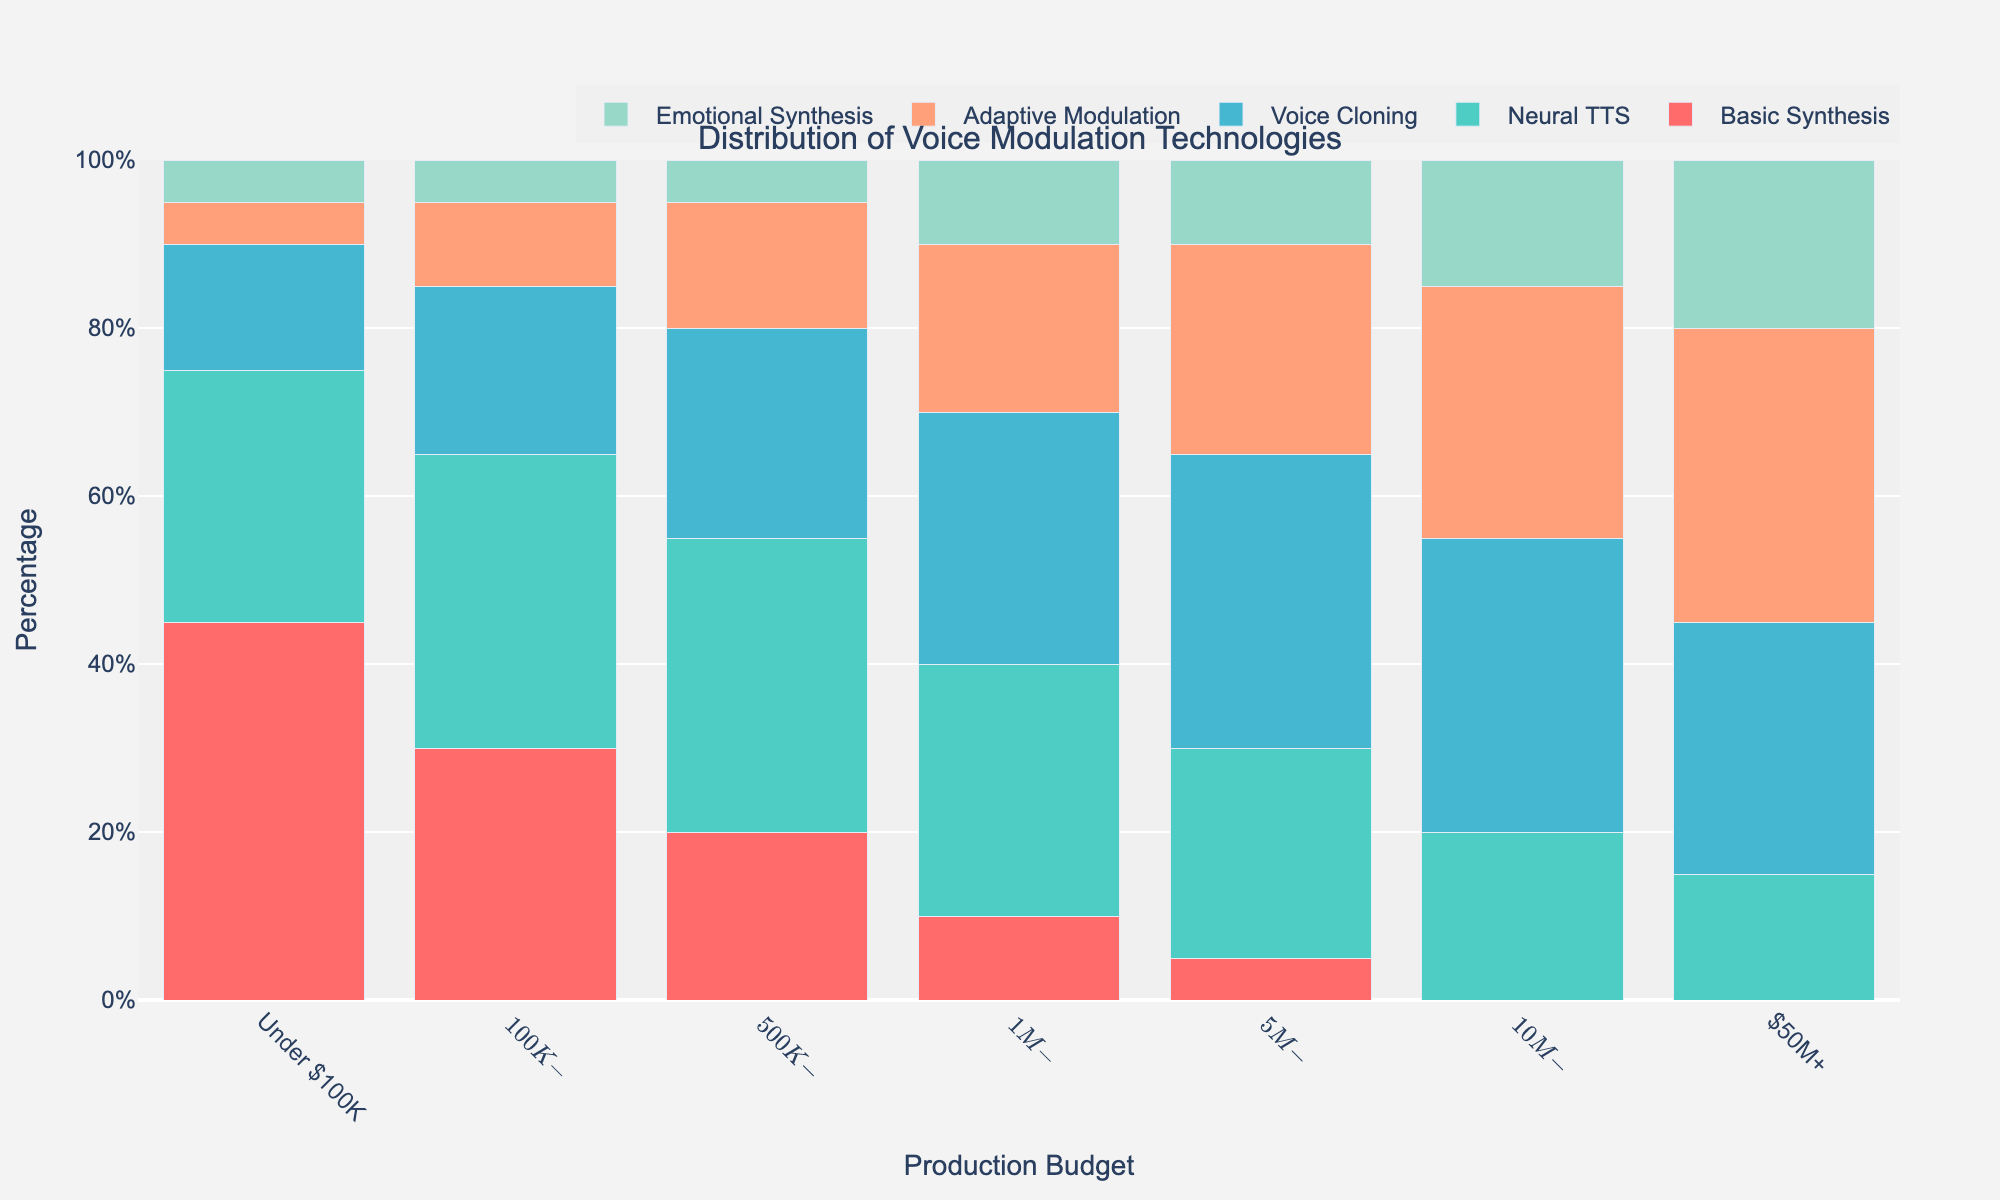What is the most commonly used voice modulation technology for production budgets under $100K? By observing the height of the bars in the "Under $100K" category, the tallest bar, representing the highest percentage, corresponds to Basic Synthesis.
Answer: Basic Synthesis Which budget range shows the highest usage of Voice Cloning? Looking at all the budget categories, the "$5M-$10M" range has the tallest bar for the Voice Cloning technology.
Answer: $5M-$10M How does the usage of Neural TTS vary from "Under $100K" to "$50M+"? The usage of Neural TTS decreases as the budget increases, starting from 30% in "Under $100K" to 15% in "$50M+".
Answer: Decreases What is the total percentage of combined use of Adaptive Modulation and Emotional Synthesis for the $1M-$5M budget range? Sum the percentages of Adaptive Modulation (20%) and Emotional Synthesis (10%) in the $1M-$5M budget range. 20% + 10% = 30%.
Answer: 30% Which technology is used the least across all budget ranges? Reviewing the figure across all budget ranges, Emotional Synthesis consistently shows the smallest percentages.
Answer: Emotional Synthesis Between which two budget ranges does the usage of Adaptive Modulation show the largest increase? When comparing Adaptive Modulation usage between budget ranges, the largest increase is from "$10M-$50M" (30%) to "$50M+" (35%), an increase of 5%.
Answer: $10M-$50M to $50M+ What is the percentage difference in the use of Basic Synthesis between the "Under $100K" budget and the "$500K-$1M" budget? Subtract the percentage of Basic Synthesis used in "$500K-$1M" (20%) from "Under $100K" (45%). 45% - 20% = 25%.
Answer: 25% How does the distribution of Emotional Synthesis change as the production budget increases? As the production budget increases, the percentage of Emotional Synthesis tends to increase from 5% in lower budgets to 20% in the highest budget range "$50M+".
Answer: Increases Which budget ranges do not use Basic Synthesis at all? Observing the bars, the budget ranges "$10M-$50M" and "$50M+" have 0% usage of Basic Synthesis.
Answer: $10M-$50M and $50M+ What is the average percentage of Neural TTS usage across all budget ranges? Add the percentages of Neural TTS across all budget ranges and divide by the number of budget ranges: (30% + 35% + 35% + 30% + 25% + 20% + 15%) / 7 ≈ 27.14%.
Answer: 27.14% 